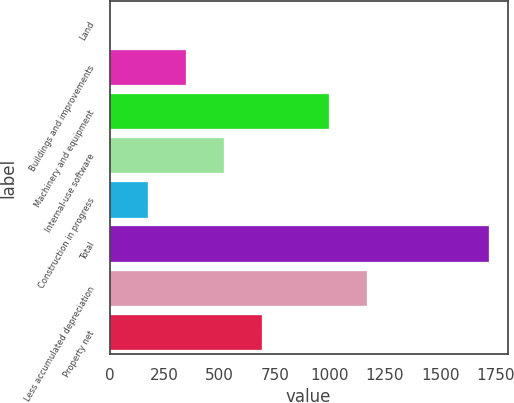Convert chart. <chart><loc_0><loc_0><loc_500><loc_500><bar_chart><fcel>Land<fcel>Buildings and improvements<fcel>Machinery and equipment<fcel>Internal-use software<fcel>Construction in progress<fcel>Total<fcel>Less accumulated depreciation<fcel>Property net<nl><fcel>3.8<fcel>347.14<fcel>996.3<fcel>518.81<fcel>175.47<fcel>1720.5<fcel>1167.97<fcel>690.48<nl></chart> 